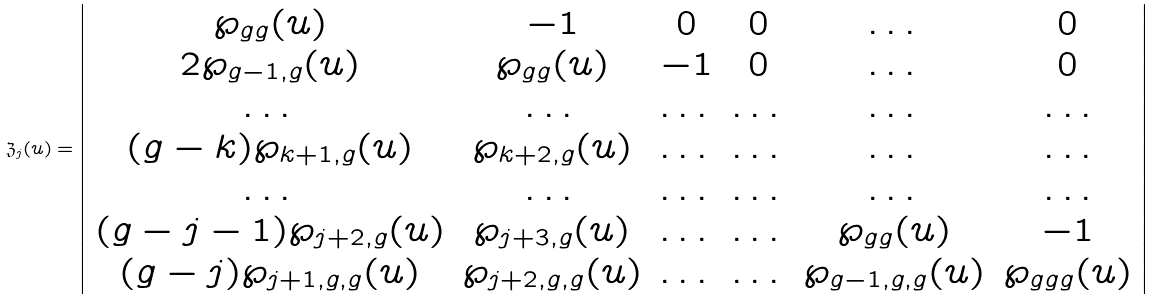<formula> <loc_0><loc_0><loc_500><loc_500>\mathfrak { Z } _ { j } ( u ) = \left | \begin{array} { c c c c c c } \wp _ { g g } ( u ) & - 1 & 0 & 0 & \dots & 0 \\ 2 \wp _ { g - 1 , g } ( u ) & \wp _ { g g } ( u ) & - 1 & 0 & \dots & 0 \\ \dots & \dots & \dots & \dots & \dots & \dots \\ ( g - k ) \wp _ { k + 1 , g } ( u ) & \wp _ { k + 2 , g } ( u ) & \dots & \dots & \dots & \dots \\ \dots & \dots & \dots & \dots & \dots & \dots \\ ( g - j - 1 ) \wp _ { j + 2 , g } ( u ) & \wp _ { j + 3 , g } ( u ) & \dots & \dots & \wp _ { g g } ( u ) & - 1 \\ ( g - j ) \wp _ { j + 1 , g , g } ( u ) & \wp _ { j + 2 , g , g } ( u ) & \dots & \dots & \wp _ { g - 1 , g , g } ( u ) & \wp _ { g g g } ( u ) \end{array} \right |</formula> 